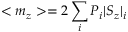<formula> <loc_0><loc_0><loc_500><loc_500>< m _ { z } > = 2 \sum _ { i } P _ { i } | S _ { z } | _ { i }</formula> 